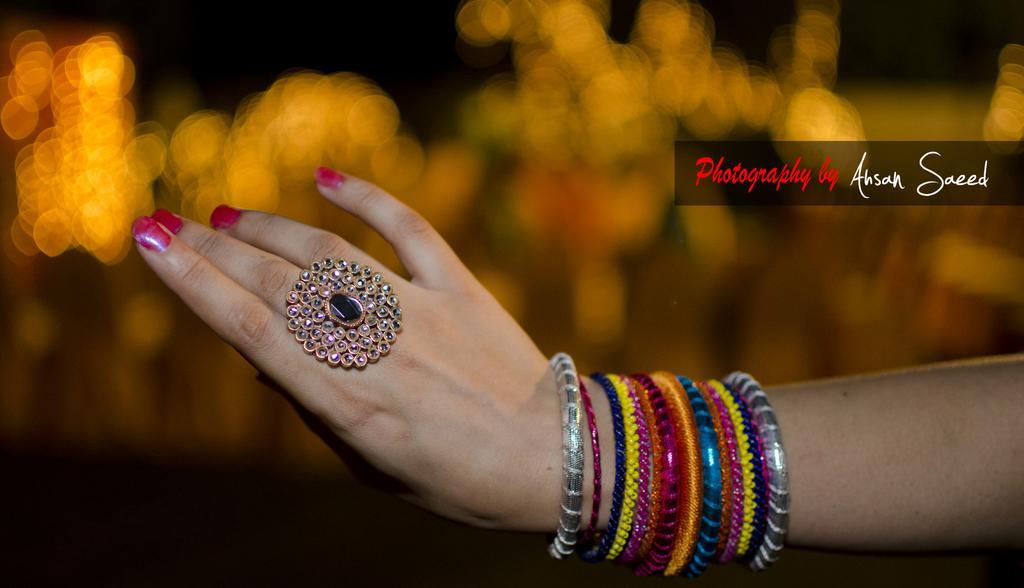Can you describe this image briefly? In the image we can see there is a hand of a person and there are bangles on his hand. There is a hand ring and there is a mirror in the middle of the hand ring. There is pink colour nail polish on the nails of a person. 